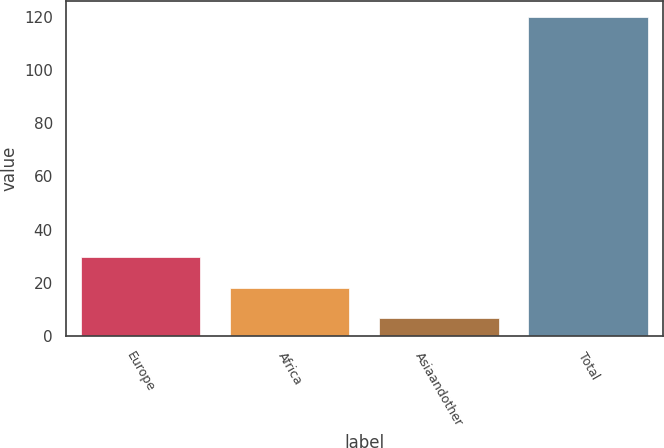Convert chart. <chart><loc_0><loc_0><loc_500><loc_500><bar_chart><fcel>Europe<fcel>Africa<fcel>Asiaandother<fcel>Total<nl><fcel>29.6<fcel>18.3<fcel>7<fcel>120<nl></chart> 